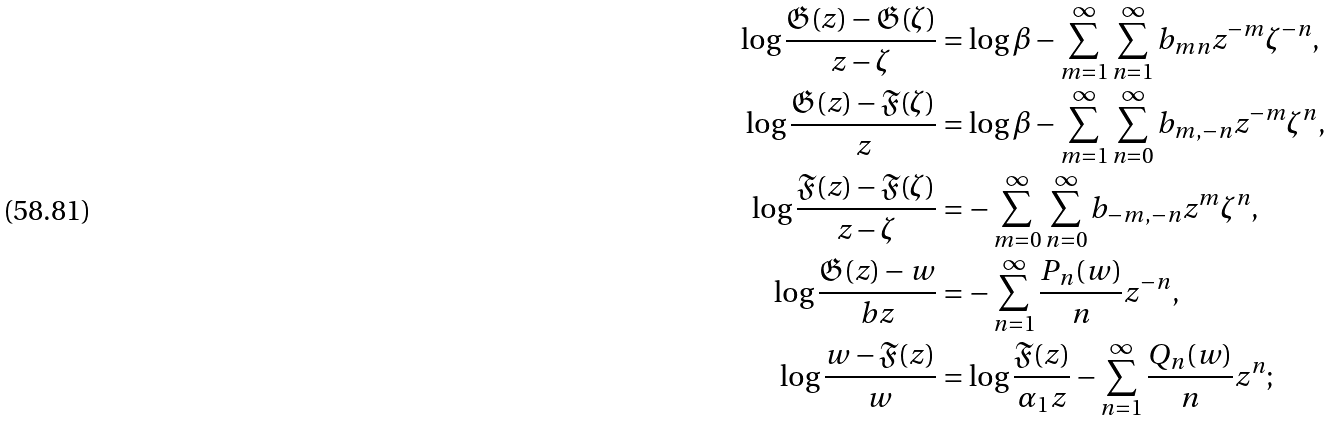Convert formula to latex. <formula><loc_0><loc_0><loc_500><loc_500>\log \frac { \mathfrak { G } ( z ) - \mathfrak { G } ( \zeta ) } { z - \zeta } & = \log \beta - \sum _ { m = 1 } ^ { \infty } \sum _ { n = 1 } ^ { \infty } b _ { m n } z ^ { - m } \zeta ^ { - n } , \\ \log \frac { \mathfrak { G } ( z ) - \mathfrak { F } ( \zeta ) } { z } & = \log \beta - \sum _ { m = 1 } ^ { \infty } \sum _ { n = 0 } ^ { \infty } b _ { m , - n } z ^ { - m } \zeta ^ { n } , \\ \log \frac { \mathfrak { F } ( z ) - \mathfrak { F } ( \zeta ) } { z - \zeta } & = - \sum _ { m = 0 } ^ { \infty } \sum _ { n = 0 } ^ { \infty } b _ { - m , - n } z ^ { m } \zeta ^ { n } , \\ \log \frac { \mathfrak { G } ( z ) - w } { b z } & = - \sum _ { n = 1 } ^ { \infty } \frac { P _ { n } ( w ) } { n } z ^ { - n } , \\ \log \frac { w - \mathfrak { F } ( z ) } { w } & = \log \frac { \mathfrak { F } ( z ) } { \alpha _ { 1 } z } - \sum _ { n = 1 } ^ { \infty } \frac { Q _ { n } ( w ) } { n } z ^ { n } ;</formula> 